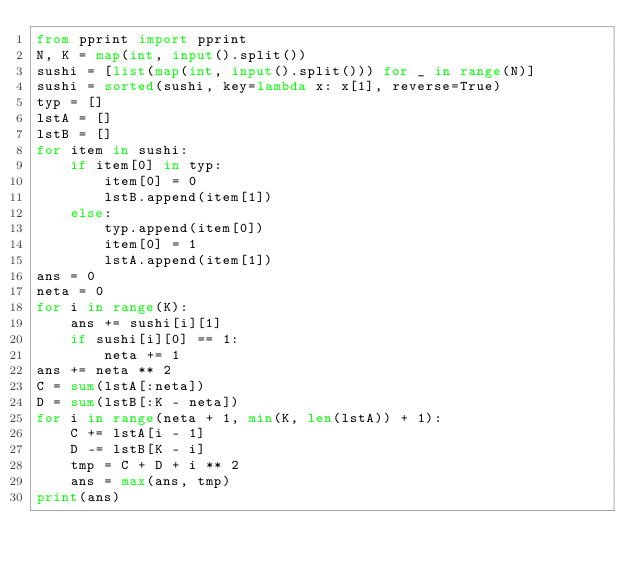Convert code to text. <code><loc_0><loc_0><loc_500><loc_500><_Python_>from pprint import pprint
N, K = map(int, input().split())
sushi = [list(map(int, input().split())) for _ in range(N)]
sushi = sorted(sushi, key=lambda x: x[1], reverse=True)
typ = []
lstA = []
lstB = []
for item in sushi:
    if item[0] in typ:
        item[0] = 0
        lstB.append(item[1])
    else:
        typ.append(item[0])
        item[0] = 1
        lstA.append(item[1])
ans = 0
neta = 0
for i in range(K):
    ans += sushi[i][1]
    if sushi[i][0] == 1:
        neta += 1
ans += neta ** 2
C = sum(lstA[:neta])
D = sum(lstB[:K - neta])
for i in range(neta + 1, min(K, len(lstA)) + 1):
    C += lstA[i - 1]
    D -= lstB[K - i]
    tmp = C + D + i ** 2
    ans = max(ans, tmp)
print(ans)</code> 